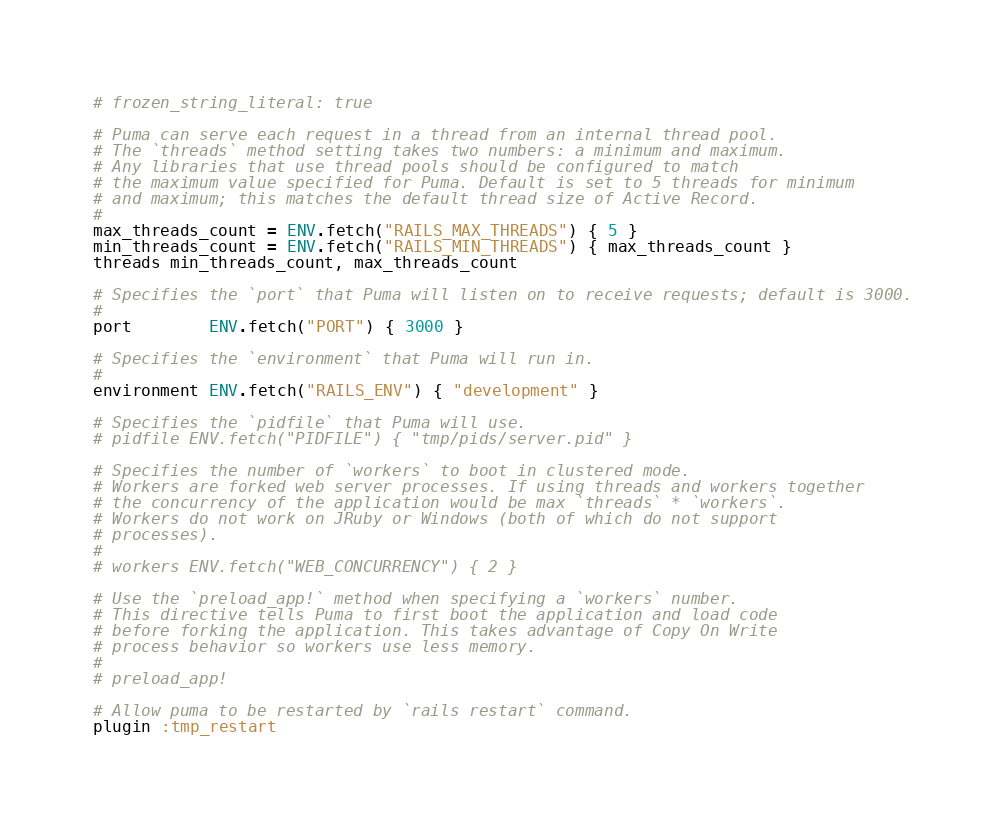Convert code to text. <code><loc_0><loc_0><loc_500><loc_500><_Ruby_># frozen_string_literal: true

# Puma can serve each request in a thread from an internal thread pool.
# The `threads` method setting takes two numbers: a minimum and maximum.
# Any libraries that use thread pools should be configured to match
# the maximum value specified for Puma. Default is set to 5 threads for minimum
# and maximum; this matches the default thread size of Active Record.
#
max_threads_count = ENV.fetch("RAILS_MAX_THREADS") { 5 }
min_threads_count = ENV.fetch("RAILS_MIN_THREADS") { max_threads_count }
threads min_threads_count, max_threads_count

# Specifies the `port` that Puma will listen on to receive requests; default is 3000.
#
port        ENV.fetch("PORT") { 3000 }

# Specifies the `environment` that Puma will run in.
#
environment ENV.fetch("RAILS_ENV") { "development" }

# Specifies the `pidfile` that Puma will use.
# pidfile ENV.fetch("PIDFILE") { "tmp/pids/server.pid" }

# Specifies the number of `workers` to boot in clustered mode.
# Workers are forked web server processes. If using threads and workers together
# the concurrency of the application would be max `threads` * `workers`.
# Workers do not work on JRuby or Windows (both of which do not support
# processes).
#
# workers ENV.fetch("WEB_CONCURRENCY") { 2 }

# Use the `preload_app!` method when specifying a `workers` number.
# This directive tells Puma to first boot the application and load code
# before forking the application. This takes advantage of Copy On Write
# process behavior so workers use less memory.
#
# preload_app!

# Allow puma to be restarted by `rails restart` command.
plugin :tmp_restart
</code> 